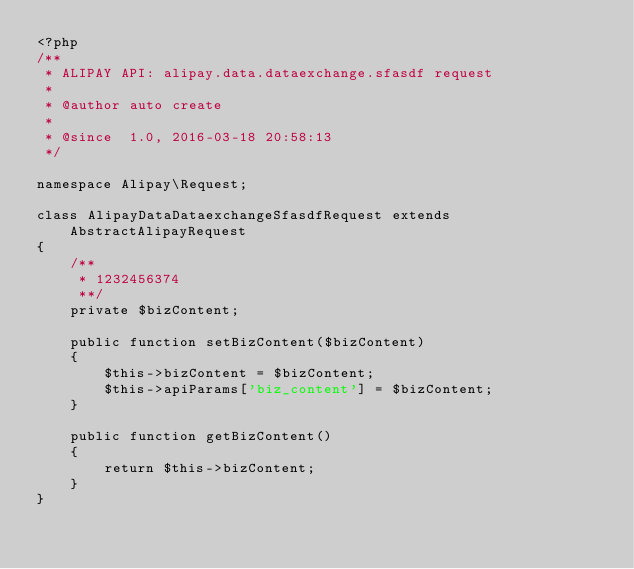Convert code to text. <code><loc_0><loc_0><loc_500><loc_500><_PHP_><?php
/**
 * ALIPAY API: alipay.data.dataexchange.sfasdf request
 *
 * @author auto create
 *
 * @since  1.0, 2016-03-18 20:58:13
 */

namespace Alipay\Request;

class AlipayDataDataexchangeSfasdfRequest extends AbstractAlipayRequest
{
    /**
     * 1232456374
     **/
    private $bizContent;

    public function setBizContent($bizContent)
    {
        $this->bizContent = $bizContent;
        $this->apiParams['biz_content'] = $bizContent;
    }

    public function getBizContent()
    {
        return $this->bizContent;
    }
}
</code> 